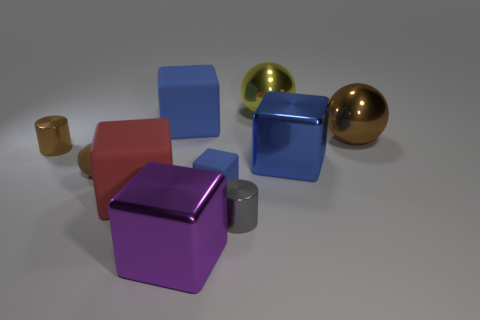Subtract all green cylinders. How many blue cubes are left? 3 Subtract all purple blocks. How many blocks are left? 4 Subtract all cyan blocks. Subtract all green balls. How many blocks are left? 5 Subtract all cylinders. How many objects are left? 8 Subtract all cyan metal balls. Subtract all brown matte objects. How many objects are left? 9 Add 5 brown cylinders. How many brown cylinders are left? 6 Add 1 gray objects. How many gray objects exist? 2 Subtract 0 gray balls. How many objects are left? 10 